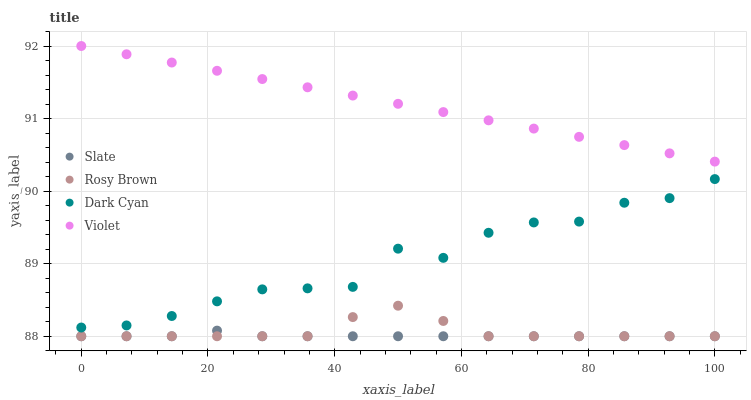Does Slate have the minimum area under the curve?
Answer yes or no. Yes. Does Violet have the maximum area under the curve?
Answer yes or no. Yes. Does Rosy Brown have the minimum area under the curve?
Answer yes or no. No. Does Rosy Brown have the maximum area under the curve?
Answer yes or no. No. Is Violet the smoothest?
Answer yes or no. Yes. Is Dark Cyan the roughest?
Answer yes or no. Yes. Is Slate the smoothest?
Answer yes or no. No. Is Slate the roughest?
Answer yes or no. No. Does Slate have the lowest value?
Answer yes or no. Yes. Does Violet have the lowest value?
Answer yes or no. No. Does Violet have the highest value?
Answer yes or no. Yes. Does Rosy Brown have the highest value?
Answer yes or no. No. Is Rosy Brown less than Dark Cyan?
Answer yes or no. Yes. Is Violet greater than Dark Cyan?
Answer yes or no. Yes. Does Slate intersect Rosy Brown?
Answer yes or no. Yes. Is Slate less than Rosy Brown?
Answer yes or no. No. Is Slate greater than Rosy Brown?
Answer yes or no. No. Does Rosy Brown intersect Dark Cyan?
Answer yes or no. No. 